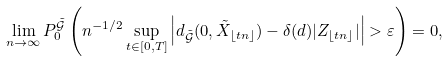Convert formula to latex. <formula><loc_0><loc_0><loc_500><loc_500>\lim _ { n \rightarrow \infty } P _ { 0 } ^ { \tilde { \mathcal { G } } } \left ( n ^ { - 1 / 2 } \sup _ { t \in [ 0 , T ] } \left | d _ { \tilde { \mathcal { G } } } ( 0 , \tilde { X } _ { \lfloor t n \rfloor } ) - \delta ( d ) | Z _ { \lfloor t n \rfloor } | \right | > \varepsilon \right ) = 0 ,</formula> 